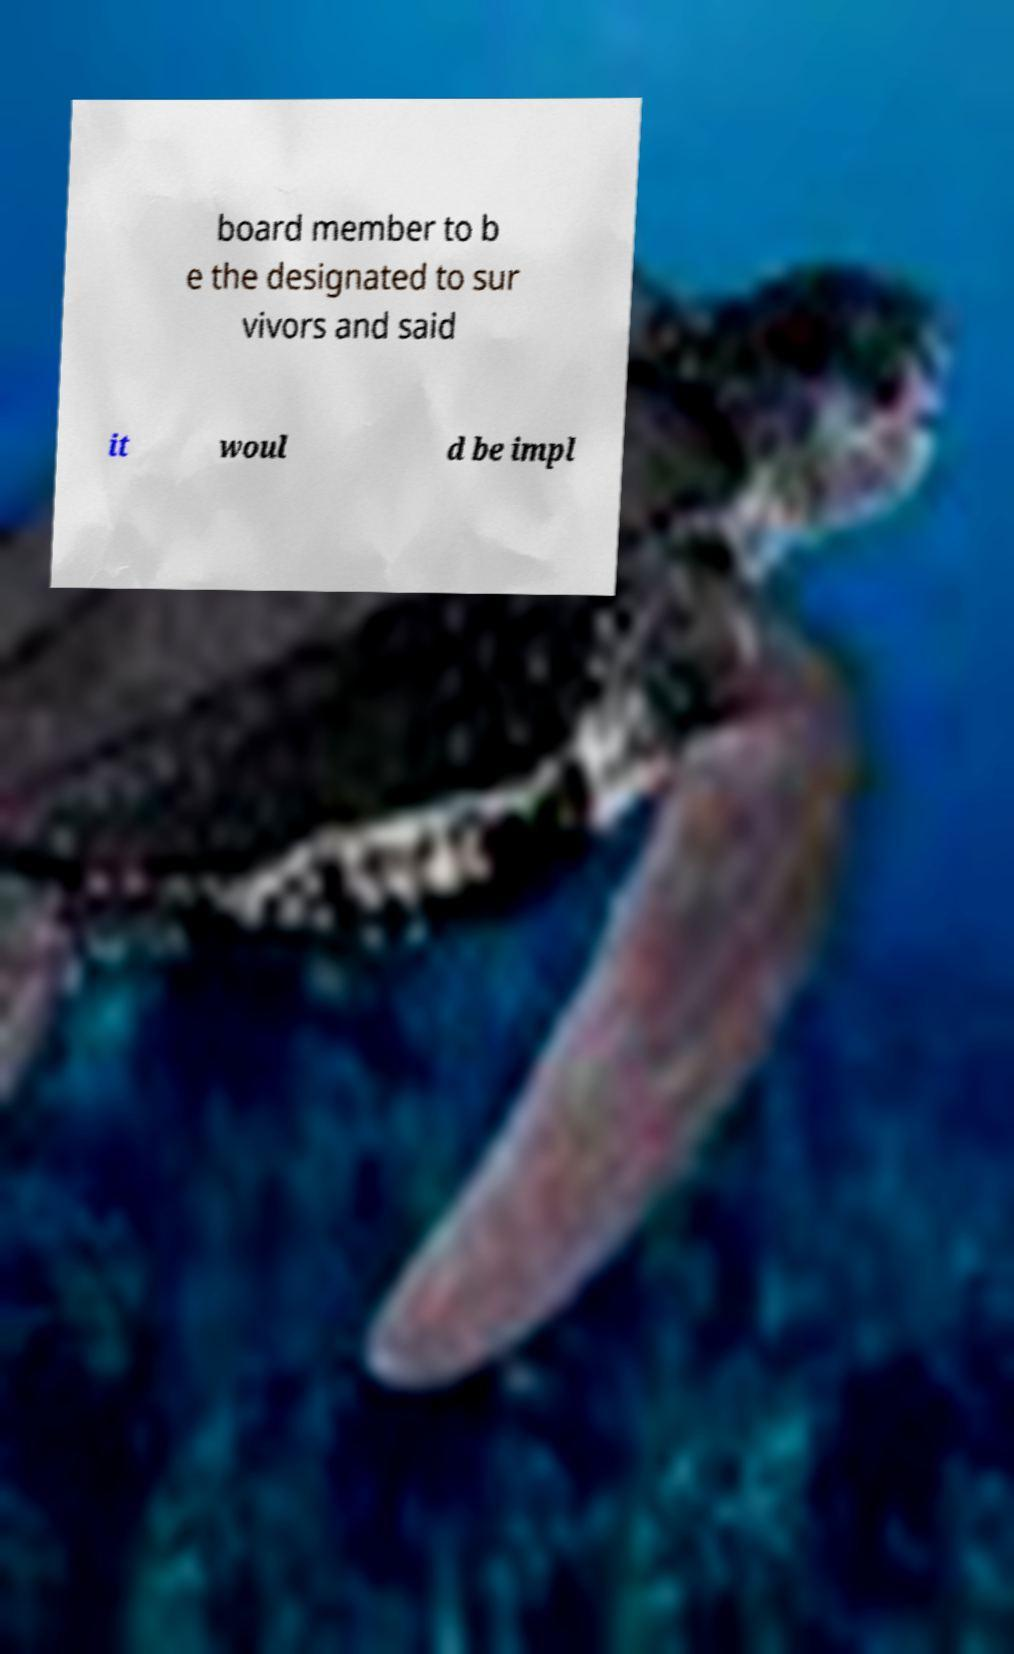Can you accurately transcribe the text from the provided image for me? board member to b e the designated to sur vivors and said it woul d be impl 